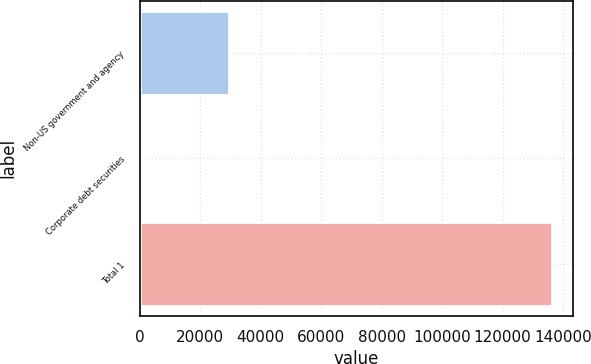Convert chart to OTSL. <chart><loc_0><loc_0><loc_500><loc_500><bar_chart><fcel>Non-US government and agency<fcel>Corporate debt securities<fcel>Total 1<nl><fcel>29451<fcel>240<fcel>136434<nl></chart> 